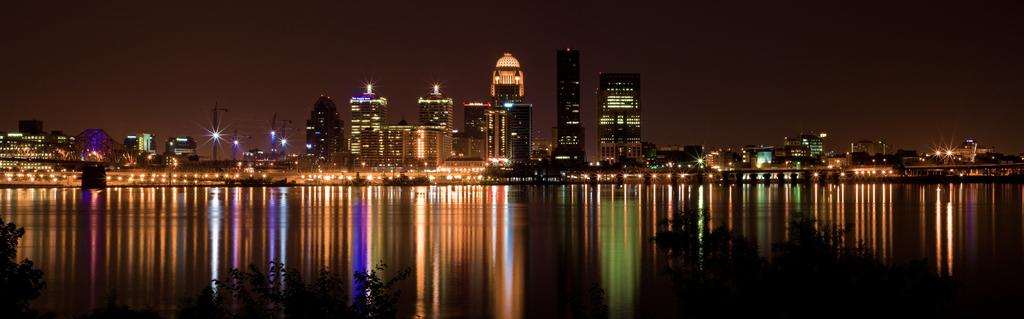What type of structures can be seen in the image? There are buildings in the image. What else is visible in the image besides the buildings? There are lights, water, trees, and the sky visible in the image. Can you describe the water in the image? The water is visible at the bottom of the image. What is the color of the sky in the image? The sky is visible in the background of the image. How many balloons are floating in the sky in the image? There are no balloons visible in the image; only lights, water, trees, and the sky can be seen. 